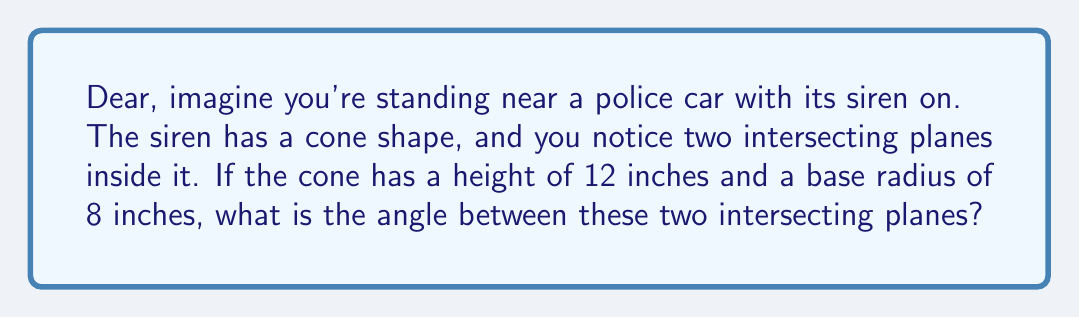Can you solve this math problem? Let's approach this step-by-step:

1) In a cone, the angle between two intersecting planes that pass through the axis is related to the cone's apex angle.

2) We need to find the apex angle of the cone first. In a right circular cone, this can be calculated using the height and base radius.

3) Let's call the apex angle $\theta$. We can find half of this angle using trigonometry:

   $$\tan(\frac{\theta}{2}) = \frac{\text{radius}}{\text{height}} = \frac{8}{12} = \frac{2}{3}$$

4) To find $\frac{\theta}{2}$, we take the arctangent (inverse tangent) of both sides:

   $$\frac{\theta}{2} = \arctan(\frac{2}{3})$$

5) The full apex angle is twice this:

   $$\theta = 2 \arctan(\frac{2}{3})$$

6) Now, the angle between two intersecting planes that pass through the axis of the cone is supplementary to the apex angle. This means that if we add these two angles, they will sum to 180°.

7) Let's call the angle between the planes $\phi$. Then:

   $$\phi + \theta = 180°$$
   $$\phi = 180° - \theta = 180° - 2 \arctan(\frac{2}{3})$$

8) We can calculate this:
   
   $$\phi = 180° - 2 \arctan(\frac{2}{3}) \approx 90.93°$$

[asy]
import geometry;

size(200);
pair O=(0,0), A=(-8,0), B=(8,0), C=(0,12);
draw(A--B--C--cycle);
draw(O--C);
label("12\"", (0,6), E);
label("8\"", (4,0), S);
label("$\theta$", (1,2), NW);
label("$\frac{\theta}{2}$", (0.5,1), NW);
[/asy]
Answer: The angle between the two intersecting planes in the cone-shaped police siren is approximately $90.93°$. 